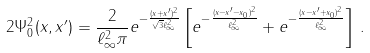Convert formula to latex. <formula><loc_0><loc_0><loc_500><loc_500>2 \Psi _ { 0 } ^ { 2 } ( x , x ^ { \prime } ) = \frac { 2 } { \ell _ { \infty } ^ { 2 } \pi } e ^ { - \frac { ( x + x ^ { \prime } ) ^ { 2 } } { \sqrt { 3 } \ell _ { \infty } ^ { 2 } } } \left [ e ^ { - \frac { ( x - x ^ { \prime } - x _ { 0 } ) ^ { 2 } } { \ell _ { \infty } ^ { 2 } } } + e ^ { - \frac { ( x - x ^ { \prime } + x _ { 0 } ) ^ { 2 } } { \ell _ { \infty } ^ { 2 } } } \right ] \, .</formula> 